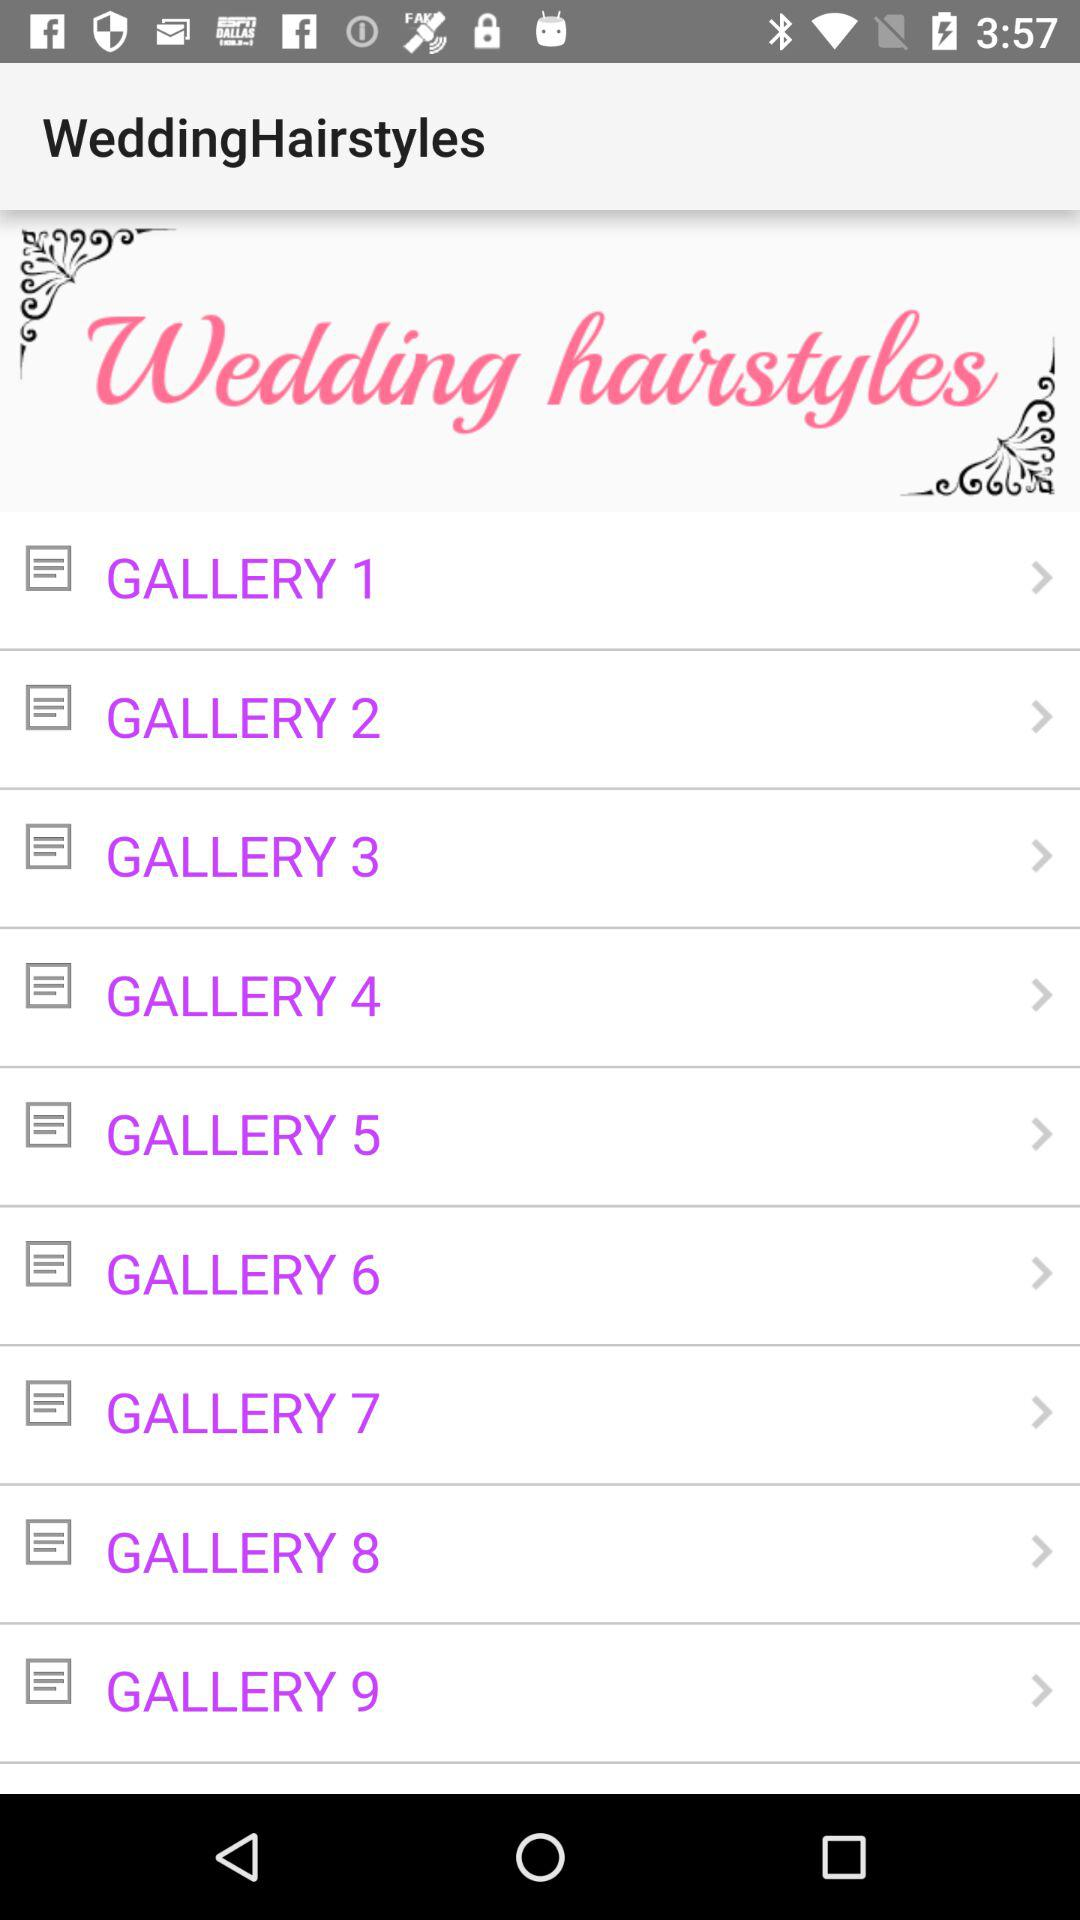How many gallery items are there?
Answer the question using a single word or phrase. 9 